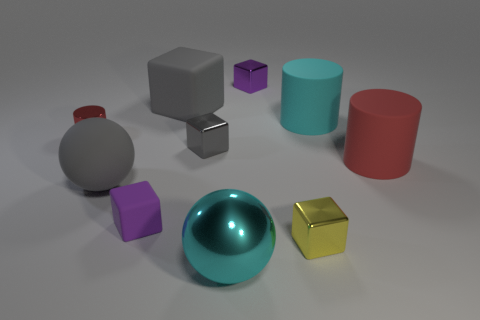Subtract all large gray rubber blocks. How many blocks are left? 4 Subtract 1 balls. How many balls are left? 1 Subtract all cyan balls. How many balls are left? 1 Subtract all cylinders. How many objects are left? 7 Subtract all blue balls. How many red cylinders are left? 2 Add 10 large brown metallic cylinders. How many large brown metallic cylinders exist? 10 Subtract 0 blue balls. How many objects are left? 10 Subtract all red spheres. Subtract all gray cylinders. How many spheres are left? 2 Subtract all small matte blocks. Subtract all metal cylinders. How many objects are left? 8 Add 4 large gray cubes. How many large gray cubes are left? 5 